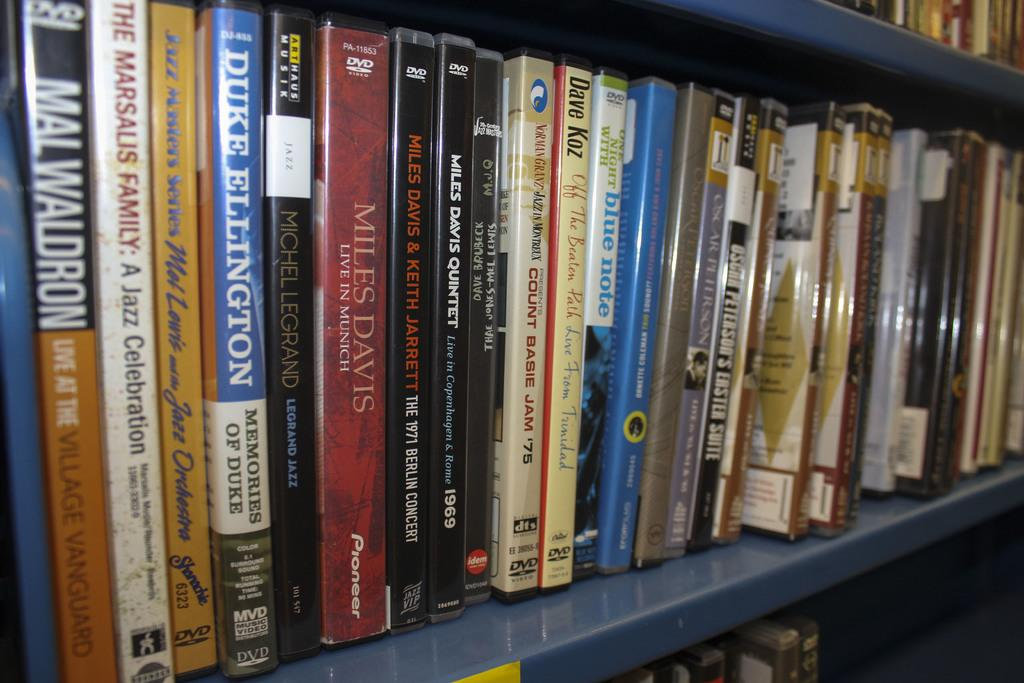<image>
Give a short and clear explanation of the subsequent image. A bookshelf holds several books, including "Live at the Village Vanguard" and "Blue Note". 